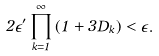Convert formula to latex. <formula><loc_0><loc_0><loc_500><loc_500>2 \epsilon ^ { \prime } \prod _ { k = 1 } ^ { \infty } { ( 1 + 3 D _ { k } ) } < \epsilon .</formula> 